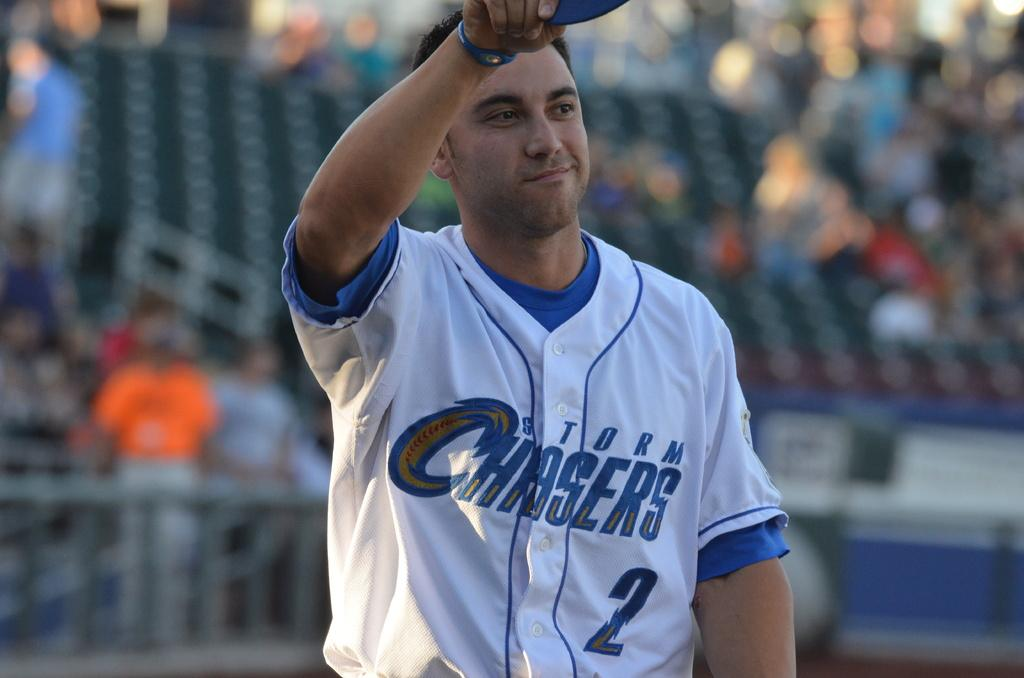<image>
Create a compact narrative representing the image presented. Man wearing a baseball jersey that says Chasers on it. 